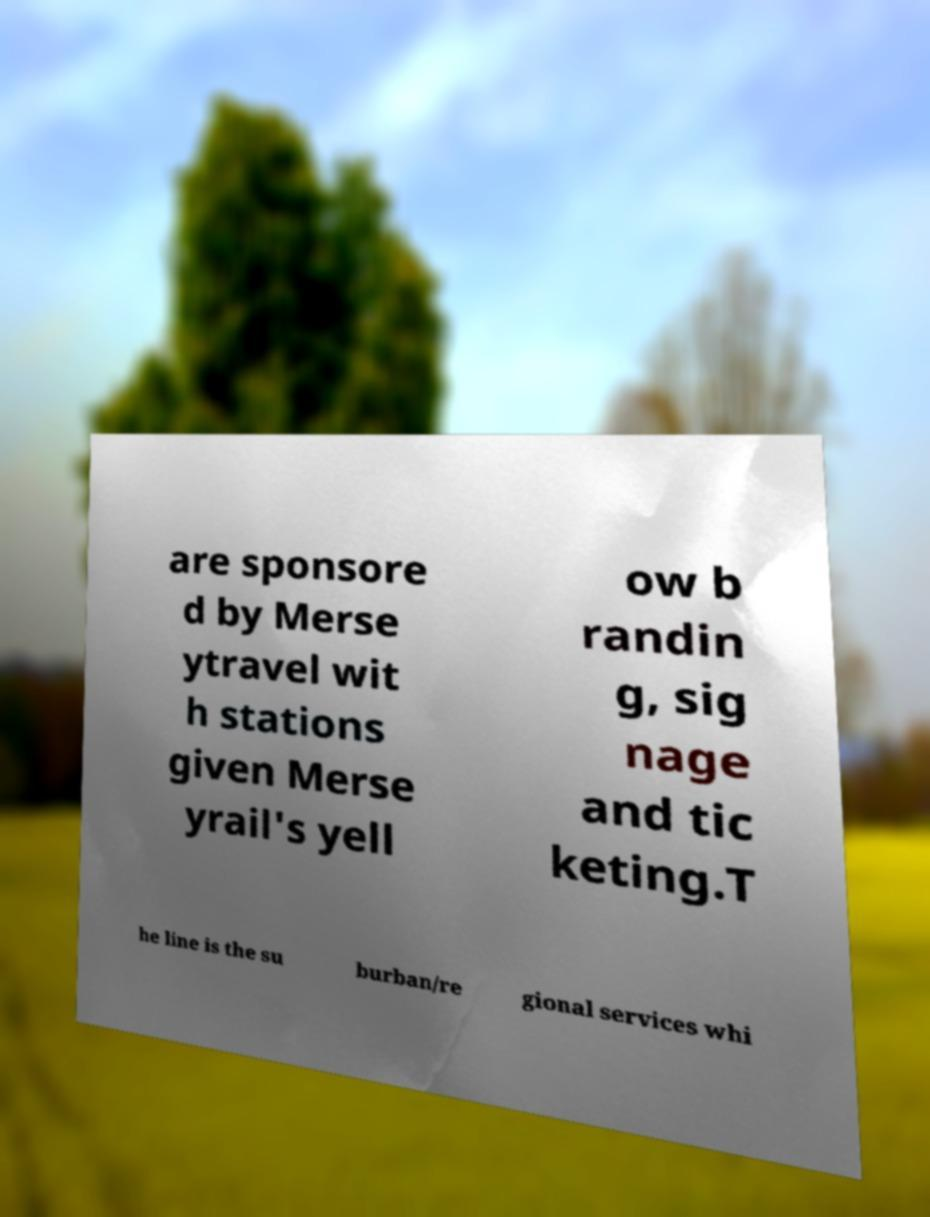Could you extract and type out the text from this image? are sponsore d by Merse ytravel wit h stations given Merse yrail's yell ow b randin g, sig nage and tic keting.T he line is the su burban/re gional services whi 